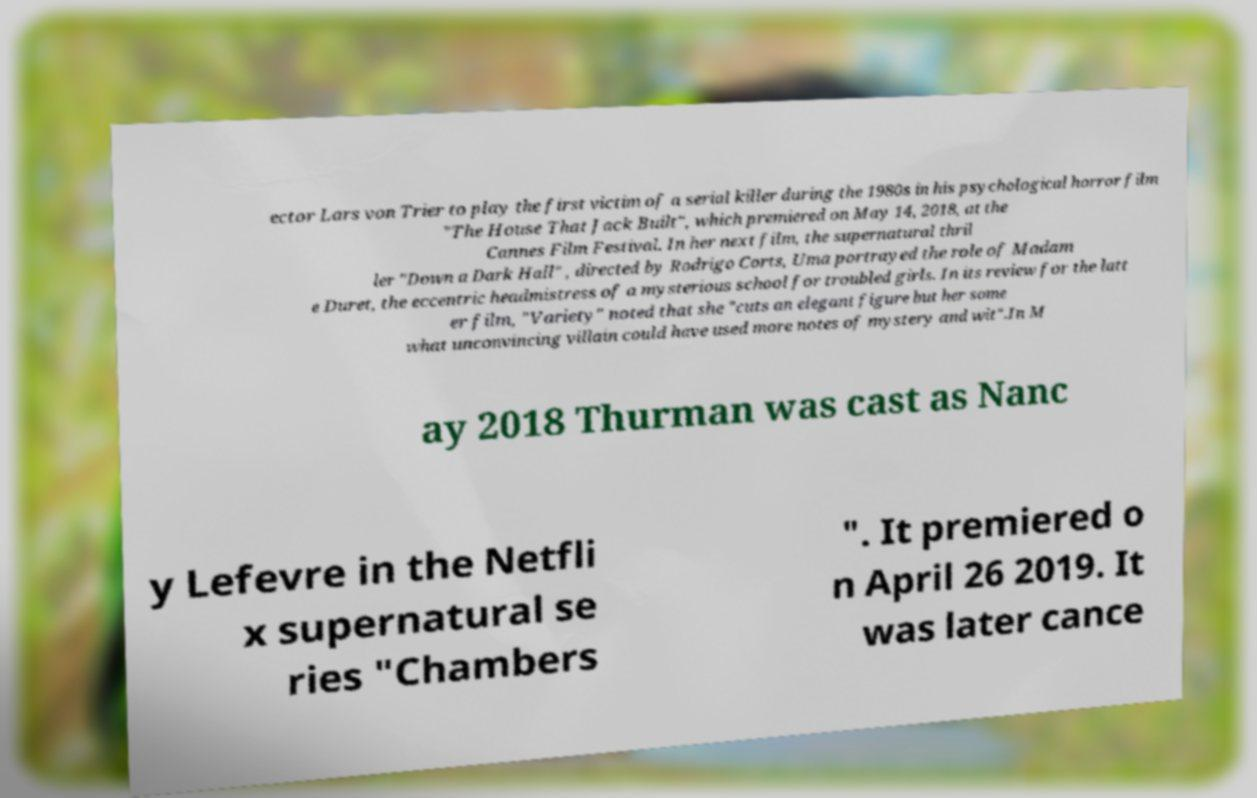Can you read and provide the text displayed in the image?This photo seems to have some interesting text. Can you extract and type it out for me? ector Lars von Trier to play the first victim of a serial killer during the 1980s in his psychological horror film "The House That Jack Built", which premiered on May 14, 2018, at the Cannes Film Festival. In her next film, the supernatural thril ler "Down a Dark Hall" , directed by Rodrigo Corts, Uma portrayed the role of Madam e Duret, the eccentric headmistress of a mysterious school for troubled girls. In its review for the latt er film, "Variety" noted that she "cuts an elegant figure but her some what unconvincing villain could have used more notes of mystery and wit".In M ay 2018 Thurman was cast as Nanc y Lefevre in the Netfli x supernatural se ries "Chambers ". It premiered o n April 26 2019. It was later cance 